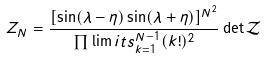Convert formula to latex. <formula><loc_0><loc_0><loc_500><loc_500>Z _ { N } = \frac { [ \sin ( \lambda - \eta ) \sin ( \lambda + \eta ) ] ^ { N ^ { 2 } } } { \prod \lim i t s _ { k = 1 } ^ { N - 1 } ( k ! ) ^ { 2 } } \, { \det } \, \mathcal { Z }</formula> 